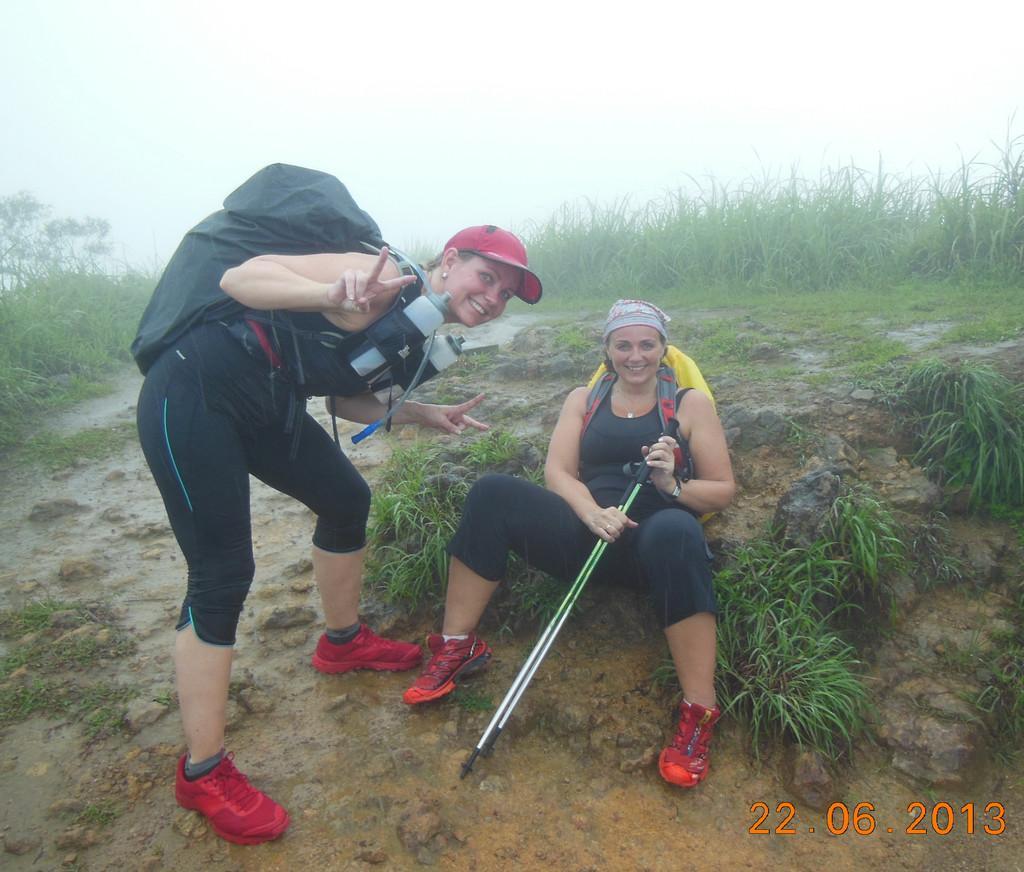In one or two sentences, can you explain what this image depicts? The girl in black T-shirt and yellow backpack is smiling. Beside her, the girl in black T-shirt who is wearing a black backpack and red cap is posing for the photo. She is smiling. In the background, we see trees and grass. At the top of the picture, we see the sky and it is a rainy day. 